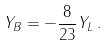<formula> <loc_0><loc_0><loc_500><loc_500>Y _ { B } = - \frac { 8 } { 2 3 } Y _ { L } \, .</formula> 